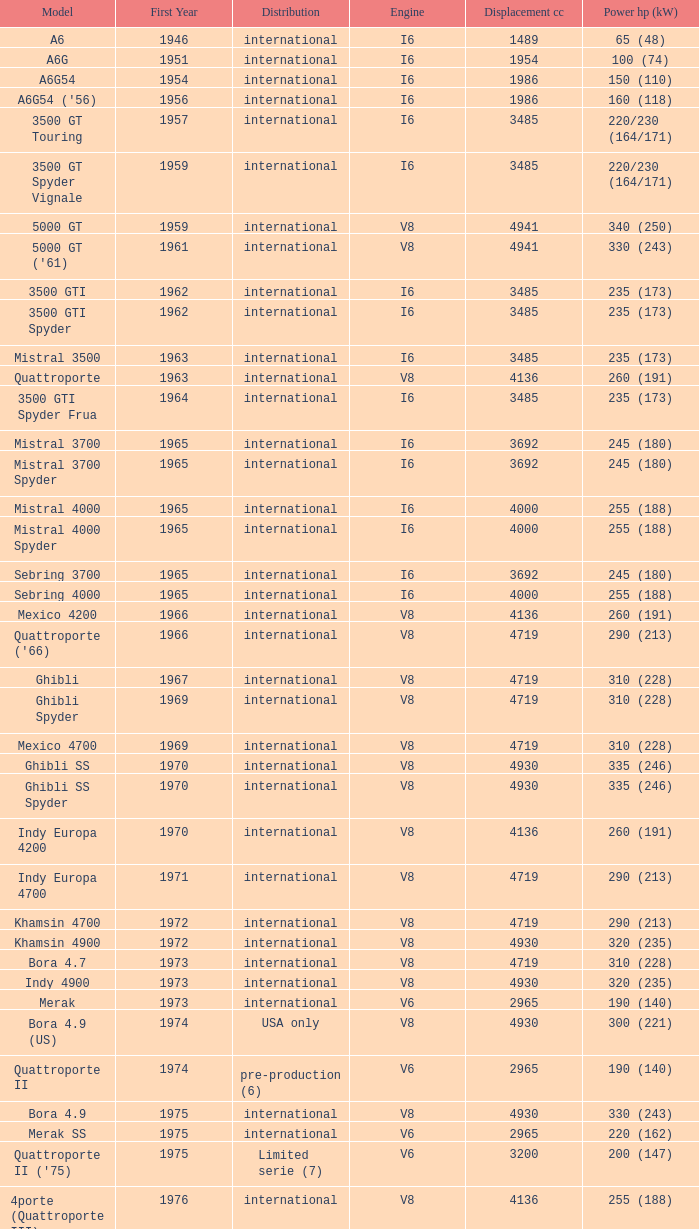For a vehicle with a first year later than 1965, "international" distribution, v6 biturbo engine, and a "425" model, what is the power hp (kw)? 200 (147). 